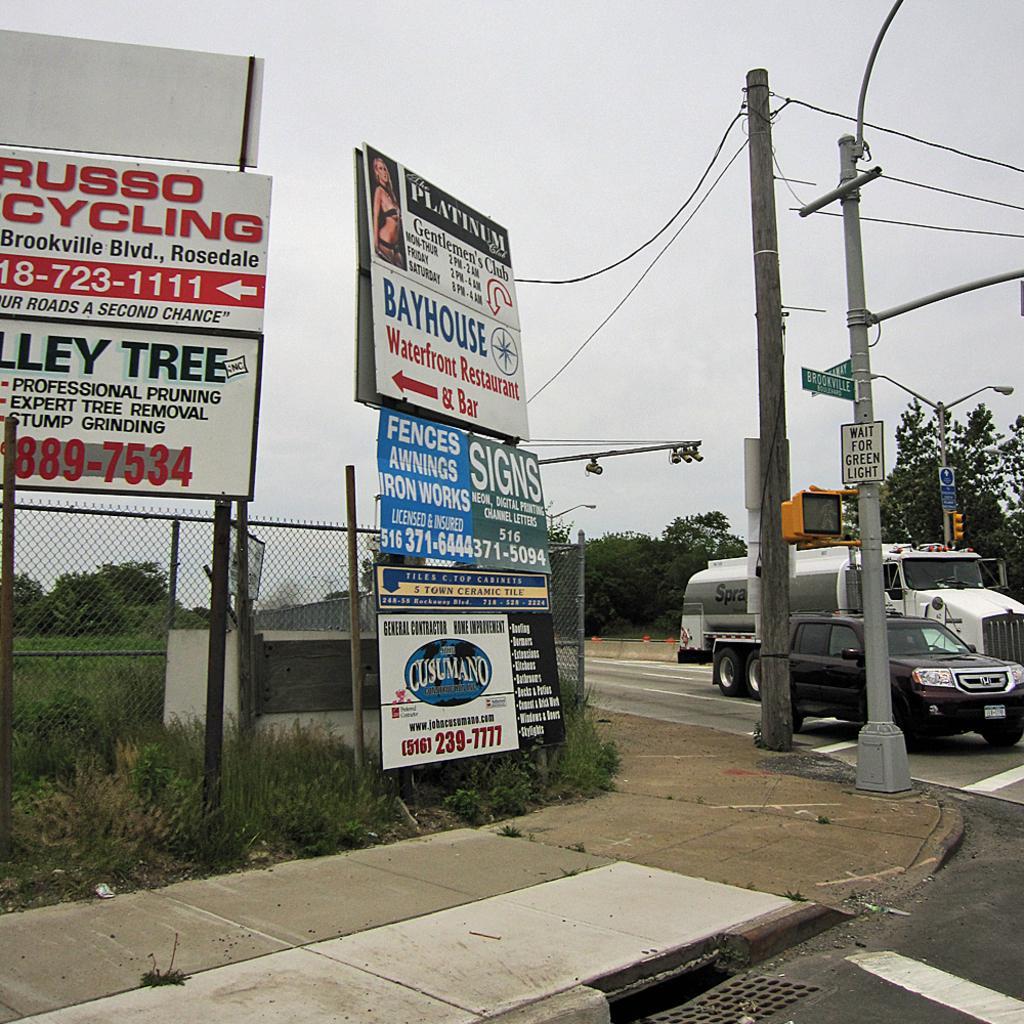Can you describe this image briefly? In this image we can see sign boards, grass, fencing, trees, poles, vehicles, road. In the background there is a sky. 